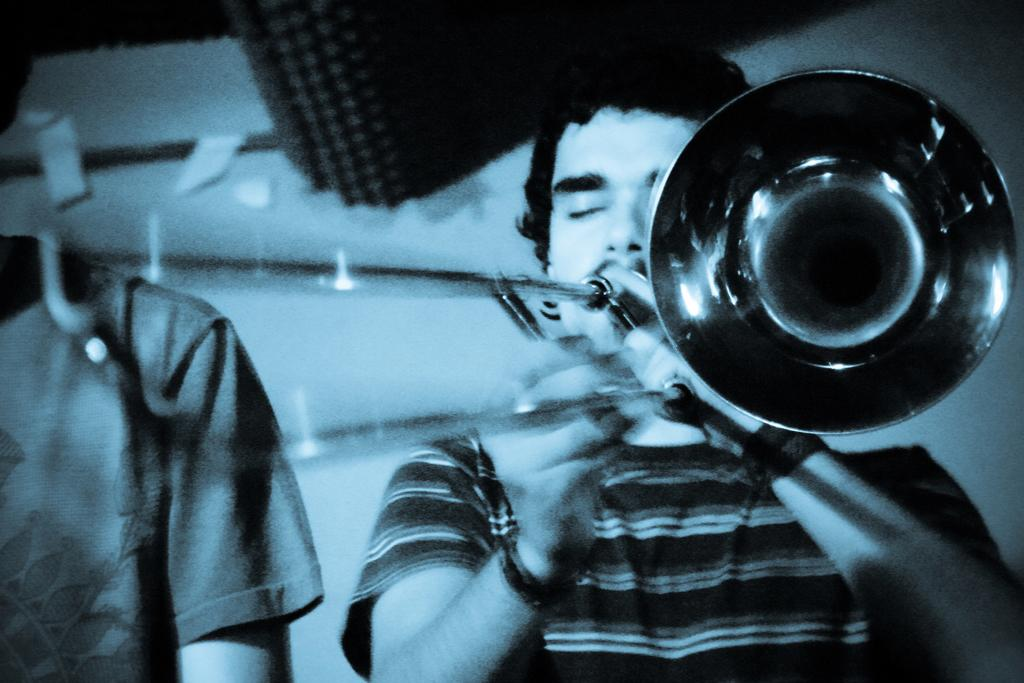What is the main subject of the image? There is a man playing a musical instrument in the image. Is there anyone else in the image besides the man playing the musical instrument? Yes, there is another person beside the man playing the musical instrument. Can you describe the background of the image? The background of the image is white and blurry. How many sheep are in the flock visible in the image? There are no sheep or flock present in the image. What is the steepness of the slope in the image? There is no slope present in the image. 